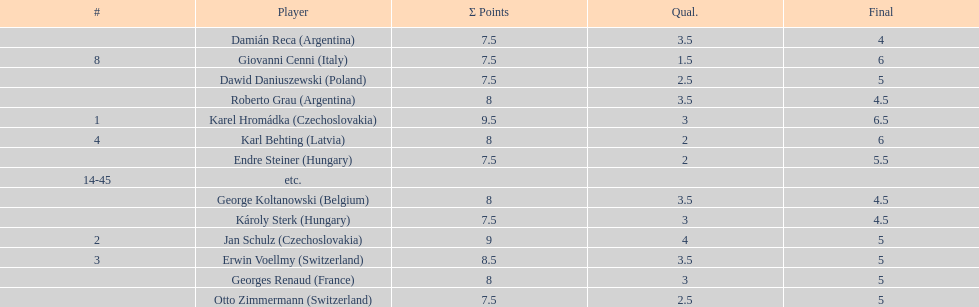Which player had the largest number of &#931; points? Karel Hromádka. 